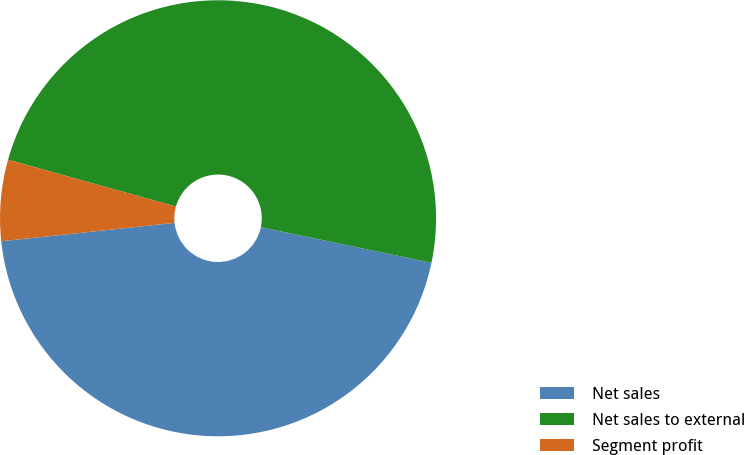Convert chart. <chart><loc_0><loc_0><loc_500><loc_500><pie_chart><fcel>Net sales<fcel>Net sales to external<fcel>Segment profit<nl><fcel>45.05%<fcel>48.95%<fcel>6.01%<nl></chart> 